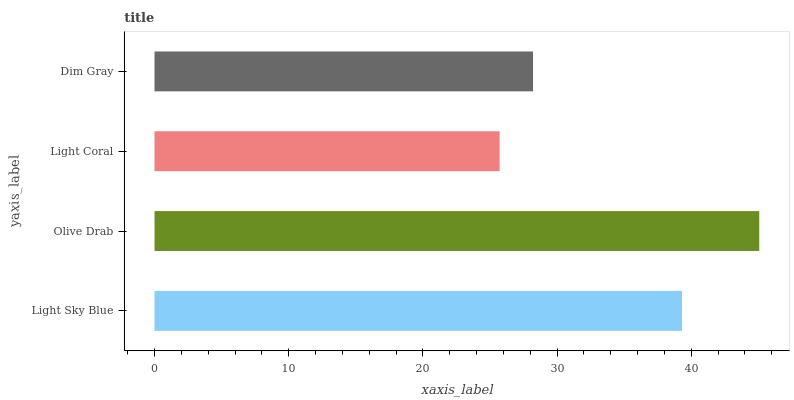Is Light Coral the minimum?
Answer yes or no. Yes. Is Olive Drab the maximum?
Answer yes or no. Yes. Is Olive Drab the minimum?
Answer yes or no. No. Is Light Coral the maximum?
Answer yes or no. No. Is Olive Drab greater than Light Coral?
Answer yes or no. Yes. Is Light Coral less than Olive Drab?
Answer yes or no. Yes. Is Light Coral greater than Olive Drab?
Answer yes or no. No. Is Olive Drab less than Light Coral?
Answer yes or no. No. Is Light Sky Blue the high median?
Answer yes or no. Yes. Is Dim Gray the low median?
Answer yes or no. Yes. Is Light Coral the high median?
Answer yes or no. No. Is Light Coral the low median?
Answer yes or no. No. 